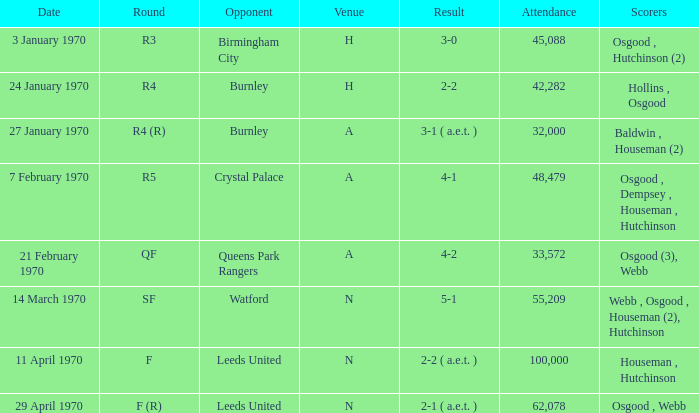What is the maximum attendance at a match with a score of 5-1? 55209.0. 